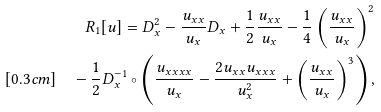<formula> <loc_0><loc_0><loc_500><loc_500>R _ { 1 } [ u ] = D _ { x } ^ { 2 } - \frac { u _ { x x } } { u _ { x } } D _ { x } + \frac { 1 } { 2 } \frac { u _ { x x } } { u _ { x } } - \frac { 1 } { 4 } \left ( \frac { u _ { x x } } { u _ { x } } \right ) ^ { 2 } \\ [ 0 . 3 c m ] \quad - \frac { 1 } { 2 } D _ { x } ^ { - 1 } \circ \left ( \frac { u _ { x x x x } } { u _ { x } } - \frac { 2 u _ { x x } u _ { x x x } } { u _ { x } ^ { 2 } } + \left ( \frac { u _ { x x } } { u _ { x } } \right ) ^ { 3 } \right ) ,</formula> 